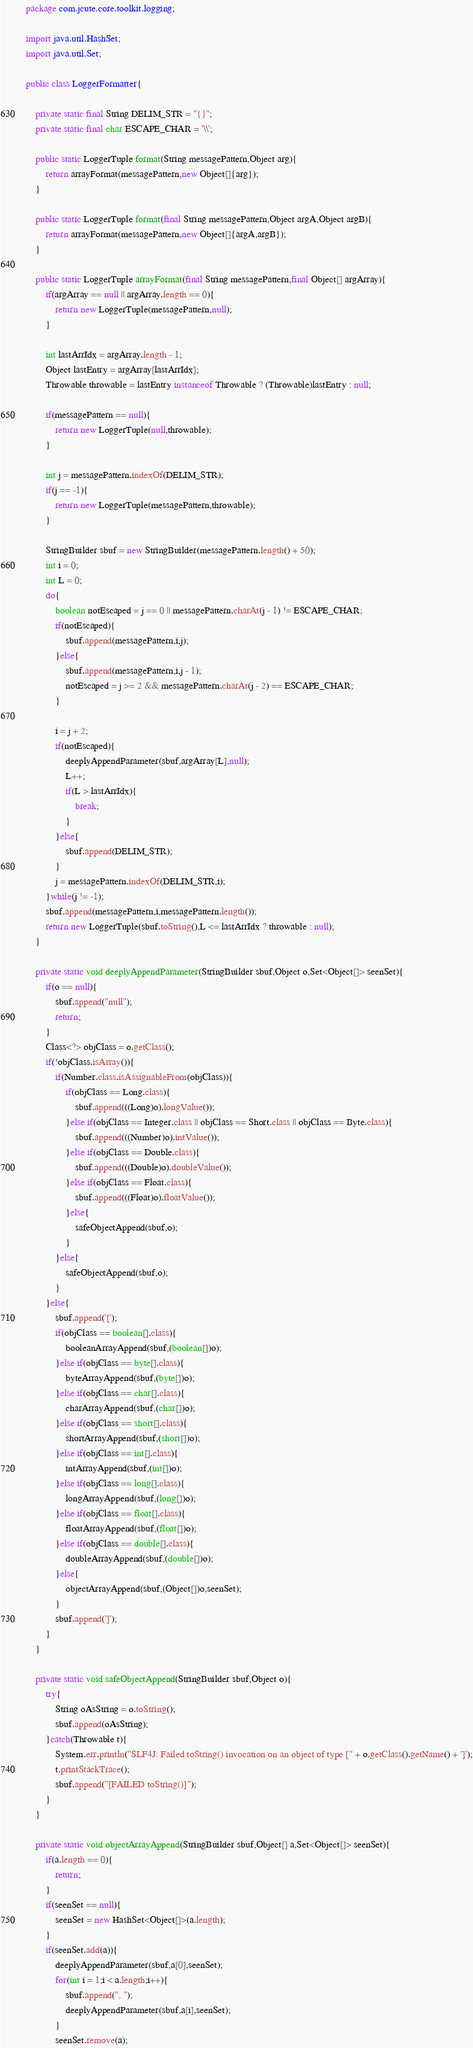<code> <loc_0><loc_0><loc_500><loc_500><_Java_>package com.jcute.core.toolkit.logging;

import java.util.HashSet;
import java.util.Set;

public class LoggerFormatter{

	private static final String DELIM_STR = "{}";
	private static final char ESCAPE_CHAR = '\\';

	public static LoggerTuple format(String messagePattern,Object arg){
		return arrayFormat(messagePattern,new Object[]{arg});
	}

	public static LoggerTuple format(final String messagePattern,Object argA,Object argB){
		return arrayFormat(messagePattern,new Object[]{argA,argB});
	}
	
	public static LoggerTuple arrayFormat(final String messagePattern,final Object[] argArray){
		if(argArray == null || argArray.length == 0){
			return new LoggerTuple(messagePattern,null);
		}

		int lastArrIdx = argArray.length - 1;
		Object lastEntry = argArray[lastArrIdx];
		Throwable throwable = lastEntry instanceof Throwable ? (Throwable)lastEntry : null;

		if(messagePattern == null){
			return new LoggerTuple(null,throwable);
		}

		int j = messagePattern.indexOf(DELIM_STR);
		if(j == -1){
			return new LoggerTuple(messagePattern,throwable);
		}

		StringBuilder sbuf = new StringBuilder(messagePattern.length() + 50);
		int i = 0;
		int L = 0;
		do{
			boolean notEscaped = j == 0 || messagePattern.charAt(j - 1) != ESCAPE_CHAR;
			if(notEscaped){
				sbuf.append(messagePattern,i,j);
			}else{
				sbuf.append(messagePattern,i,j - 1);
				notEscaped = j >= 2 && messagePattern.charAt(j - 2) == ESCAPE_CHAR;
			}

			i = j + 2;
			if(notEscaped){
				deeplyAppendParameter(sbuf,argArray[L],null);
				L++;
				if(L > lastArrIdx){
					break;
				}
			}else{
				sbuf.append(DELIM_STR);
			}
			j = messagePattern.indexOf(DELIM_STR,i);
		}while(j != -1);
		sbuf.append(messagePattern,i,messagePattern.length());
		return new LoggerTuple(sbuf.toString(),L <= lastArrIdx ? throwable : null);
	}

	private static void deeplyAppendParameter(StringBuilder sbuf,Object o,Set<Object[]> seenSet){
		if(o == null){
			sbuf.append("null");
			return;
		}
		Class<?> objClass = o.getClass();
		if(!objClass.isArray()){
			if(Number.class.isAssignableFrom(objClass)){
				if(objClass == Long.class){
					sbuf.append(((Long)o).longValue());
				}else if(objClass == Integer.class || objClass == Short.class || objClass == Byte.class){
					sbuf.append(((Number)o).intValue());
				}else if(objClass == Double.class){
					sbuf.append(((Double)o).doubleValue());
				}else if(objClass == Float.class){
					sbuf.append(((Float)o).floatValue());
				}else{
					safeObjectAppend(sbuf,o);
				}
			}else{
				safeObjectAppend(sbuf,o);
			}
		}else{
			sbuf.append('[');
			if(objClass == boolean[].class){
				booleanArrayAppend(sbuf,(boolean[])o);
			}else if(objClass == byte[].class){
				byteArrayAppend(sbuf,(byte[])o);
			}else if(objClass == char[].class){
				charArrayAppend(sbuf,(char[])o);
			}else if(objClass == short[].class){
				shortArrayAppend(sbuf,(short[])o);
			}else if(objClass == int[].class){
				intArrayAppend(sbuf,(int[])o);
			}else if(objClass == long[].class){
				longArrayAppend(sbuf,(long[])o);
			}else if(objClass == float[].class){
				floatArrayAppend(sbuf,(float[])o);
			}else if(objClass == double[].class){
				doubleArrayAppend(sbuf,(double[])o);
			}else{
				objectArrayAppend(sbuf,(Object[])o,seenSet);
			}
			sbuf.append(']');
		}
	}

	private static void safeObjectAppend(StringBuilder sbuf,Object o){
		try{
			String oAsString = o.toString();
			sbuf.append(oAsString);
		}catch(Throwable t){
			System.err.println("SLF4J: Failed toString() invocation on an object of type [" + o.getClass().getName() + ']');
			t.printStackTrace();
			sbuf.append("[FAILED toString()]");
		}
	}

	private static void objectArrayAppend(StringBuilder sbuf,Object[] a,Set<Object[]> seenSet){
		if(a.length == 0){
			return;
		}
		if(seenSet == null){
			seenSet = new HashSet<Object[]>(a.length);
		}
		if(seenSet.add(a)){
			deeplyAppendParameter(sbuf,a[0],seenSet);
			for(int i = 1;i < a.length;i++){
				sbuf.append(", ");
				deeplyAppendParameter(sbuf,a[i],seenSet);
			}
			seenSet.remove(a);</code> 